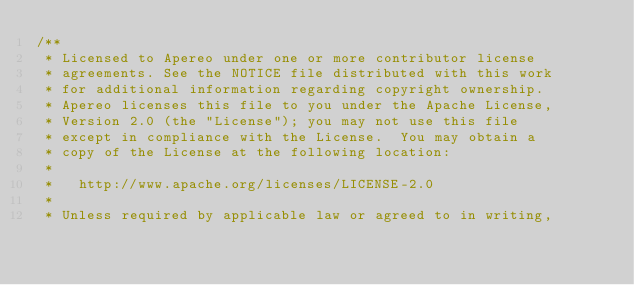<code> <loc_0><loc_0><loc_500><loc_500><_Java_>/**
 * Licensed to Apereo under one or more contributor license
 * agreements. See the NOTICE file distributed with this work
 * for additional information regarding copyright ownership.
 * Apereo licenses this file to you under the Apache License,
 * Version 2.0 (the "License"); you may not use this file
 * except in compliance with the License.  You may obtain a
 * copy of the License at the following location:
 *
 *   http://www.apache.org/licenses/LICENSE-2.0
 *
 * Unless required by applicable law or agreed to in writing,</code> 